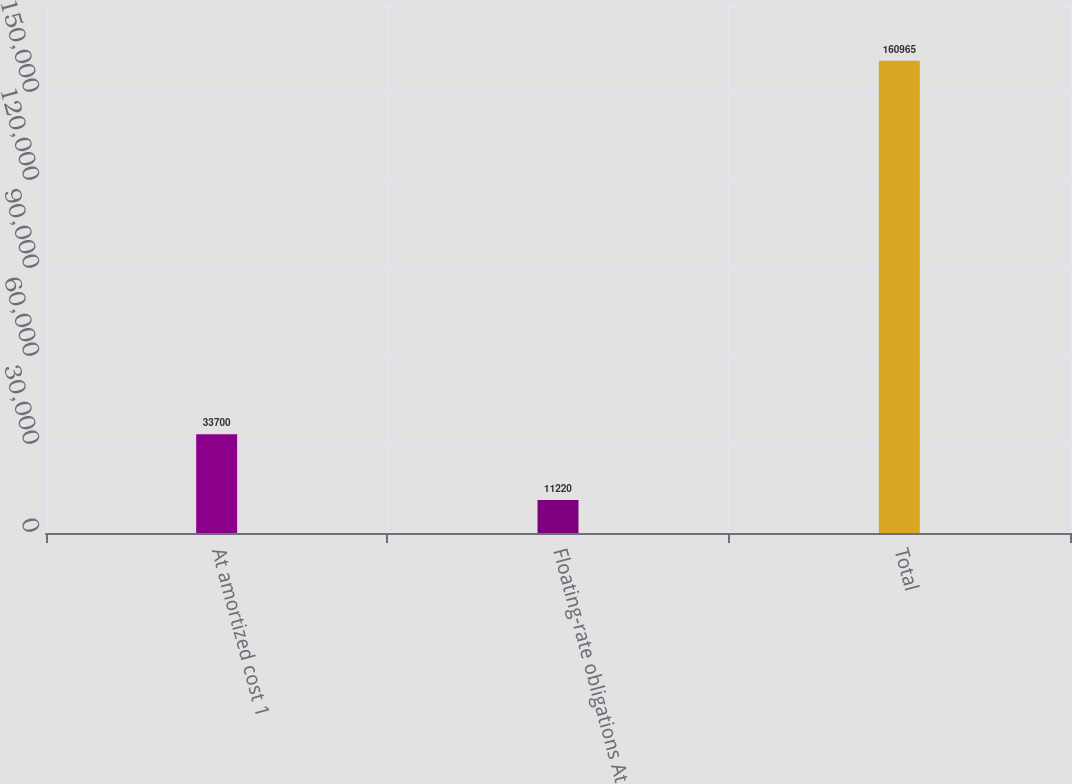Convert chart. <chart><loc_0><loc_0><loc_500><loc_500><bar_chart><fcel>At amortized cost 1<fcel>Floating-rate obligations At<fcel>Total<nl><fcel>33700<fcel>11220<fcel>160965<nl></chart> 